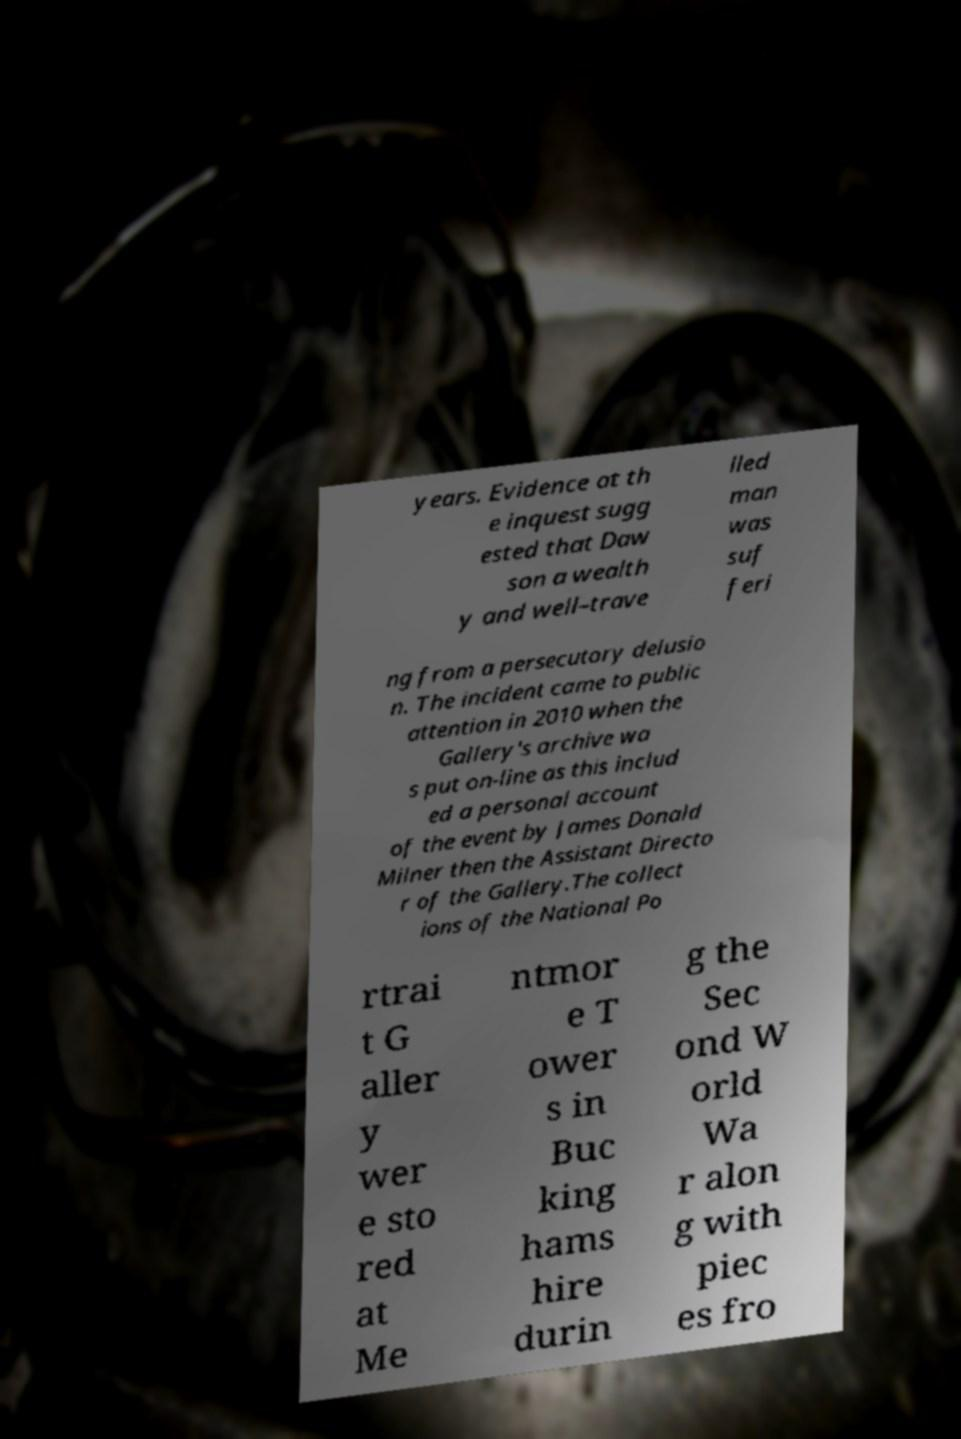Please read and relay the text visible in this image. What does it say? years. Evidence at th e inquest sugg ested that Daw son a wealth y and well–trave lled man was suf feri ng from a persecutory delusio n. The incident came to public attention in 2010 when the Gallery's archive wa s put on-line as this includ ed a personal account of the event by James Donald Milner then the Assistant Directo r of the Gallery.The collect ions of the National Po rtrai t G aller y wer e sto red at Me ntmor e T ower s in Buc king hams hire durin g the Sec ond W orld Wa r alon g with piec es fro 